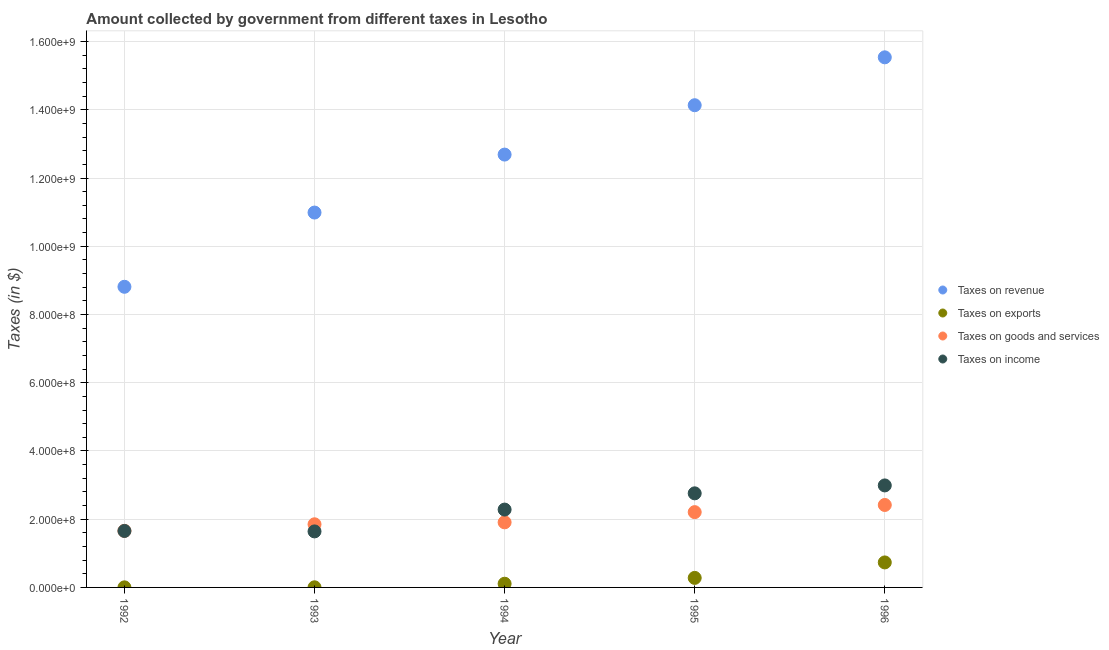How many different coloured dotlines are there?
Keep it short and to the point. 4. What is the amount collected as tax on revenue in 1993?
Your answer should be compact. 1.10e+09. Across all years, what is the maximum amount collected as tax on exports?
Offer a terse response. 7.33e+07. Across all years, what is the minimum amount collected as tax on exports?
Make the answer very short. 2.14e+05. In which year was the amount collected as tax on exports minimum?
Ensure brevity in your answer.  1992. What is the total amount collected as tax on income in the graph?
Your answer should be compact. 1.13e+09. What is the difference between the amount collected as tax on exports in 1995 and that in 1996?
Your answer should be compact. -4.53e+07. What is the difference between the amount collected as tax on exports in 1993 and the amount collected as tax on revenue in 1996?
Offer a terse response. -1.55e+09. What is the average amount collected as tax on exports per year?
Your answer should be very brief. 2.25e+07. In the year 1992, what is the difference between the amount collected as tax on revenue and amount collected as tax on income?
Ensure brevity in your answer.  7.16e+08. In how many years, is the amount collected as tax on exports greater than 680000000 $?
Your answer should be very brief. 0. What is the ratio of the amount collected as tax on revenue in 1994 to that in 1995?
Your answer should be very brief. 0.9. What is the difference between the highest and the second highest amount collected as tax on exports?
Give a very brief answer. 4.53e+07. What is the difference between the highest and the lowest amount collected as tax on income?
Give a very brief answer. 1.35e+08. Is the sum of the amount collected as tax on revenue in 1992 and 1996 greater than the maximum amount collected as tax on income across all years?
Provide a succinct answer. Yes. Is it the case that in every year, the sum of the amount collected as tax on exports and amount collected as tax on revenue is greater than the sum of amount collected as tax on goods and amount collected as tax on income?
Give a very brief answer. Yes. Is it the case that in every year, the sum of the amount collected as tax on revenue and amount collected as tax on exports is greater than the amount collected as tax on goods?
Your answer should be compact. Yes. Does the amount collected as tax on goods monotonically increase over the years?
Your response must be concise. Yes. Is the amount collected as tax on revenue strictly greater than the amount collected as tax on income over the years?
Provide a succinct answer. Yes. Is the amount collected as tax on income strictly less than the amount collected as tax on goods over the years?
Keep it short and to the point. No. How many dotlines are there?
Keep it short and to the point. 4. How many years are there in the graph?
Your answer should be very brief. 5. How many legend labels are there?
Make the answer very short. 4. How are the legend labels stacked?
Offer a terse response. Vertical. What is the title of the graph?
Your answer should be very brief. Amount collected by government from different taxes in Lesotho. Does "Secondary" appear as one of the legend labels in the graph?
Provide a short and direct response. No. What is the label or title of the X-axis?
Ensure brevity in your answer.  Year. What is the label or title of the Y-axis?
Your answer should be very brief. Taxes (in $). What is the Taxes (in $) in Taxes on revenue in 1992?
Your answer should be very brief. 8.81e+08. What is the Taxes (in $) of Taxes on exports in 1992?
Offer a terse response. 2.14e+05. What is the Taxes (in $) of Taxes on goods and services in 1992?
Your answer should be very brief. 1.66e+08. What is the Taxes (in $) of Taxes on income in 1992?
Offer a terse response. 1.66e+08. What is the Taxes (in $) of Taxes on revenue in 1993?
Provide a succinct answer. 1.10e+09. What is the Taxes (in $) of Taxes on exports in 1993?
Keep it short and to the point. 3.65e+05. What is the Taxes (in $) in Taxes on goods and services in 1993?
Provide a short and direct response. 1.85e+08. What is the Taxes (in $) in Taxes on income in 1993?
Provide a succinct answer. 1.64e+08. What is the Taxes (in $) in Taxes on revenue in 1994?
Provide a succinct answer. 1.27e+09. What is the Taxes (in $) in Taxes on exports in 1994?
Make the answer very short. 1.08e+07. What is the Taxes (in $) in Taxes on goods and services in 1994?
Keep it short and to the point. 1.91e+08. What is the Taxes (in $) of Taxes on income in 1994?
Your answer should be compact. 2.28e+08. What is the Taxes (in $) in Taxes on revenue in 1995?
Offer a terse response. 1.41e+09. What is the Taxes (in $) of Taxes on exports in 1995?
Your answer should be very brief. 2.79e+07. What is the Taxes (in $) in Taxes on goods and services in 1995?
Make the answer very short. 2.21e+08. What is the Taxes (in $) of Taxes on income in 1995?
Ensure brevity in your answer.  2.76e+08. What is the Taxes (in $) of Taxes on revenue in 1996?
Your response must be concise. 1.55e+09. What is the Taxes (in $) in Taxes on exports in 1996?
Give a very brief answer. 7.33e+07. What is the Taxes (in $) in Taxes on goods and services in 1996?
Make the answer very short. 2.42e+08. What is the Taxes (in $) in Taxes on income in 1996?
Offer a very short reply. 2.99e+08. Across all years, what is the maximum Taxes (in $) in Taxes on revenue?
Your answer should be compact. 1.55e+09. Across all years, what is the maximum Taxes (in $) of Taxes on exports?
Ensure brevity in your answer.  7.33e+07. Across all years, what is the maximum Taxes (in $) in Taxes on goods and services?
Keep it short and to the point. 2.42e+08. Across all years, what is the maximum Taxes (in $) of Taxes on income?
Ensure brevity in your answer.  2.99e+08. Across all years, what is the minimum Taxes (in $) of Taxes on revenue?
Give a very brief answer. 8.81e+08. Across all years, what is the minimum Taxes (in $) in Taxes on exports?
Offer a very short reply. 2.14e+05. Across all years, what is the minimum Taxes (in $) of Taxes on goods and services?
Provide a succinct answer. 1.66e+08. Across all years, what is the minimum Taxes (in $) of Taxes on income?
Your response must be concise. 1.64e+08. What is the total Taxes (in $) in Taxes on revenue in the graph?
Your response must be concise. 6.22e+09. What is the total Taxes (in $) in Taxes on exports in the graph?
Provide a short and direct response. 1.13e+08. What is the total Taxes (in $) of Taxes on goods and services in the graph?
Your answer should be very brief. 1.00e+09. What is the total Taxes (in $) in Taxes on income in the graph?
Offer a terse response. 1.13e+09. What is the difference between the Taxes (in $) in Taxes on revenue in 1992 and that in 1993?
Offer a terse response. -2.18e+08. What is the difference between the Taxes (in $) of Taxes on exports in 1992 and that in 1993?
Give a very brief answer. -1.51e+05. What is the difference between the Taxes (in $) in Taxes on goods and services in 1992 and that in 1993?
Ensure brevity in your answer.  -1.93e+07. What is the difference between the Taxes (in $) of Taxes on income in 1992 and that in 1993?
Your answer should be compact. 1.33e+06. What is the difference between the Taxes (in $) in Taxes on revenue in 1992 and that in 1994?
Make the answer very short. -3.88e+08. What is the difference between the Taxes (in $) in Taxes on exports in 1992 and that in 1994?
Ensure brevity in your answer.  -1.06e+07. What is the difference between the Taxes (in $) in Taxes on goods and services in 1992 and that in 1994?
Ensure brevity in your answer.  -2.50e+07. What is the difference between the Taxes (in $) in Taxes on income in 1992 and that in 1994?
Offer a terse response. -6.27e+07. What is the difference between the Taxes (in $) of Taxes on revenue in 1992 and that in 1995?
Keep it short and to the point. -5.32e+08. What is the difference between the Taxes (in $) of Taxes on exports in 1992 and that in 1995?
Give a very brief answer. -2.77e+07. What is the difference between the Taxes (in $) in Taxes on goods and services in 1992 and that in 1995?
Your response must be concise. -5.49e+07. What is the difference between the Taxes (in $) of Taxes on income in 1992 and that in 1995?
Provide a short and direct response. -1.10e+08. What is the difference between the Taxes (in $) in Taxes on revenue in 1992 and that in 1996?
Provide a short and direct response. -6.73e+08. What is the difference between the Taxes (in $) in Taxes on exports in 1992 and that in 1996?
Your answer should be very brief. -7.31e+07. What is the difference between the Taxes (in $) of Taxes on goods and services in 1992 and that in 1996?
Keep it short and to the point. -7.59e+07. What is the difference between the Taxes (in $) in Taxes on income in 1992 and that in 1996?
Provide a succinct answer. -1.33e+08. What is the difference between the Taxes (in $) in Taxes on revenue in 1993 and that in 1994?
Offer a very short reply. -1.70e+08. What is the difference between the Taxes (in $) of Taxes on exports in 1993 and that in 1994?
Give a very brief answer. -1.05e+07. What is the difference between the Taxes (in $) in Taxes on goods and services in 1993 and that in 1994?
Offer a very short reply. -5.73e+06. What is the difference between the Taxes (in $) of Taxes on income in 1993 and that in 1994?
Give a very brief answer. -6.40e+07. What is the difference between the Taxes (in $) in Taxes on revenue in 1993 and that in 1995?
Provide a succinct answer. -3.15e+08. What is the difference between the Taxes (in $) of Taxes on exports in 1993 and that in 1995?
Ensure brevity in your answer.  -2.76e+07. What is the difference between the Taxes (in $) of Taxes on goods and services in 1993 and that in 1995?
Your response must be concise. -3.56e+07. What is the difference between the Taxes (in $) of Taxes on income in 1993 and that in 1995?
Give a very brief answer. -1.12e+08. What is the difference between the Taxes (in $) in Taxes on revenue in 1993 and that in 1996?
Offer a terse response. -4.55e+08. What is the difference between the Taxes (in $) of Taxes on exports in 1993 and that in 1996?
Your answer should be very brief. -7.29e+07. What is the difference between the Taxes (in $) in Taxes on goods and services in 1993 and that in 1996?
Offer a terse response. -5.66e+07. What is the difference between the Taxes (in $) of Taxes on income in 1993 and that in 1996?
Offer a terse response. -1.35e+08. What is the difference between the Taxes (in $) of Taxes on revenue in 1994 and that in 1995?
Make the answer very short. -1.45e+08. What is the difference between the Taxes (in $) in Taxes on exports in 1994 and that in 1995?
Make the answer very short. -1.71e+07. What is the difference between the Taxes (in $) of Taxes on goods and services in 1994 and that in 1995?
Offer a terse response. -2.99e+07. What is the difference between the Taxes (in $) in Taxes on income in 1994 and that in 1995?
Offer a terse response. -4.76e+07. What is the difference between the Taxes (in $) in Taxes on revenue in 1994 and that in 1996?
Your answer should be compact. -2.85e+08. What is the difference between the Taxes (in $) in Taxes on exports in 1994 and that in 1996?
Ensure brevity in your answer.  -6.24e+07. What is the difference between the Taxes (in $) of Taxes on goods and services in 1994 and that in 1996?
Your response must be concise. -5.09e+07. What is the difference between the Taxes (in $) in Taxes on income in 1994 and that in 1996?
Keep it short and to the point. -7.08e+07. What is the difference between the Taxes (in $) in Taxes on revenue in 1995 and that in 1996?
Make the answer very short. -1.40e+08. What is the difference between the Taxes (in $) in Taxes on exports in 1995 and that in 1996?
Give a very brief answer. -4.53e+07. What is the difference between the Taxes (in $) of Taxes on goods and services in 1995 and that in 1996?
Provide a succinct answer. -2.10e+07. What is the difference between the Taxes (in $) of Taxes on income in 1995 and that in 1996?
Ensure brevity in your answer.  -2.32e+07. What is the difference between the Taxes (in $) in Taxes on revenue in 1992 and the Taxes (in $) in Taxes on exports in 1993?
Ensure brevity in your answer.  8.81e+08. What is the difference between the Taxes (in $) of Taxes on revenue in 1992 and the Taxes (in $) of Taxes on goods and services in 1993?
Your answer should be very brief. 6.96e+08. What is the difference between the Taxes (in $) of Taxes on revenue in 1992 and the Taxes (in $) of Taxes on income in 1993?
Make the answer very short. 7.17e+08. What is the difference between the Taxes (in $) of Taxes on exports in 1992 and the Taxes (in $) of Taxes on goods and services in 1993?
Make the answer very short. -1.85e+08. What is the difference between the Taxes (in $) in Taxes on exports in 1992 and the Taxes (in $) in Taxes on income in 1993?
Offer a terse response. -1.64e+08. What is the difference between the Taxes (in $) in Taxes on goods and services in 1992 and the Taxes (in $) in Taxes on income in 1993?
Make the answer very short. 1.60e+06. What is the difference between the Taxes (in $) of Taxes on revenue in 1992 and the Taxes (in $) of Taxes on exports in 1994?
Ensure brevity in your answer.  8.70e+08. What is the difference between the Taxes (in $) in Taxes on revenue in 1992 and the Taxes (in $) in Taxes on goods and services in 1994?
Your response must be concise. 6.90e+08. What is the difference between the Taxes (in $) of Taxes on revenue in 1992 and the Taxes (in $) of Taxes on income in 1994?
Keep it short and to the point. 6.53e+08. What is the difference between the Taxes (in $) of Taxes on exports in 1992 and the Taxes (in $) of Taxes on goods and services in 1994?
Provide a succinct answer. -1.91e+08. What is the difference between the Taxes (in $) in Taxes on exports in 1992 and the Taxes (in $) in Taxes on income in 1994?
Ensure brevity in your answer.  -2.28e+08. What is the difference between the Taxes (in $) of Taxes on goods and services in 1992 and the Taxes (in $) of Taxes on income in 1994?
Offer a terse response. -6.24e+07. What is the difference between the Taxes (in $) in Taxes on revenue in 1992 and the Taxes (in $) in Taxes on exports in 1995?
Give a very brief answer. 8.53e+08. What is the difference between the Taxes (in $) in Taxes on revenue in 1992 and the Taxes (in $) in Taxes on goods and services in 1995?
Provide a succinct answer. 6.61e+08. What is the difference between the Taxes (in $) in Taxes on revenue in 1992 and the Taxes (in $) in Taxes on income in 1995?
Make the answer very short. 6.05e+08. What is the difference between the Taxes (in $) in Taxes on exports in 1992 and the Taxes (in $) in Taxes on goods and services in 1995?
Your response must be concise. -2.20e+08. What is the difference between the Taxes (in $) of Taxes on exports in 1992 and the Taxes (in $) of Taxes on income in 1995?
Keep it short and to the point. -2.76e+08. What is the difference between the Taxes (in $) of Taxes on goods and services in 1992 and the Taxes (in $) of Taxes on income in 1995?
Provide a short and direct response. -1.10e+08. What is the difference between the Taxes (in $) in Taxes on revenue in 1992 and the Taxes (in $) in Taxes on exports in 1996?
Give a very brief answer. 8.08e+08. What is the difference between the Taxes (in $) of Taxes on revenue in 1992 and the Taxes (in $) of Taxes on goods and services in 1996?
Provide a short and direct response. 6.40e+08. What is the difference between the Taxes (in $) of Taxes on revenue in 1992 and the Taxes (in $) of Taxes on income in 1996?
Keep it short and to the point. 5.82e+08. What is the difference between the Taxes (in $) in Taxes on exports in 1992 and the Taxes (in $) in Taxes on goods and services in 1996?
Offer a very short reply. -2.41e+08. What is the difference between the Taxes (in $) in Taxes on exports in 1992 and the Taxes (in $) in Taxes on income in 1996?
Make the answer very short. -2.99e+08. What is the difference between the Taxes (in $) of Taxes on goods and services in 1992 and the Taxes (in $) of Taxes on income in 1996?
Make the answer very short. -1.33e+08. What is the difference between the Taxes (in $) in Taxes on revenue in 1993 and the Taxes (in $) in Taxes on exports in 1994?
Offer a very short reply. 1.09e+09. What is the difference between the Taxes (in $) in Taxes on revenue in 1993 and the Taxes (in $) in Taxes on goods and services in 1994?
Your response must be concise. 9.08e+08. What is the difference between the Taxes (in $) of Taxes on revenue in 1993 and the Taxes (in $) of Taxes on income in 1994?
Your response must be concise. 8.71e+08. What is the difference between the Taxes (in $) in Taxes on exports in 1993 and the Taxes (in $) in Taxes on goods and services in 1994?
Offer a very short reply. -1.90e+08. What is the difference between the Taxes (in $) in Taxes on exports in 1993 and the Taxes (in $) in Taxes on income in 1994?
Your answer should be compact. -2.28e+08. What is the difference between the Taxes (in $) in Taxes on goods and services in 1993 and the Taxes (in $) in Taxes on income in 1994?
Offer a very short reply. -4.31e+07. What is the difference between the Taxes (in $) of Taxes on revenue in 1993 and the Taxes (in $) of Taxes on exports in 1995?
Provide a succinct answer. 1.07e+09. What is the difference between the Taxes (in $) in Taxes on revenue in 1993 and the Taxes (in $) in Taxes on goods and services in 1995?
Provide a short and direct response. 8.78e+08. What is the difference between the Taxes (in $) of Taxes on revenue in 1993 and the Taxes (in $) of Taxes on income in 1995?
Offer a terse response. 8.23e+08. What is the difference between the Taxes (in $) in Taxes on exports in 1993 and the Taxes (in $) in Taxes on goods and services in 1995?
Keep it short and to the point. -2.20e+08. What is the difference between the Taxes (in $) of Taxes on exports in 1993 and the Taxes (in $) of Taxes on income in 1995?
Your answer should be very brief. -2.75e+08. What is the difference between the Taxes (in $) in Taxes on goods and services in 1993 and the Taxes (in $) in Taxes on income in 1995?
Offer a very short reply. -9.07e+07. What is the difference between the Taxes (in $) in Taxes on revenue in 1993 and the Taxes (in $) in Taxes on exports in 1996?
Make the answer very short. 1.03e+09. What is the difference between the Taxes (in $) of Taxes on revenue in 1993 and the Taxes (in $) of Taxes on goods and services in 1996?
Your answer should be compact. 8.57e+08. What is the difference between the Taxes (in $) in Taxes on revenue in 1993 and the Taxes (in $) in Taxes on income in 1996?
Provide a short and direct response. 8.00e+08. What is the difference between the Taxes (in $) in Taxes on exports in 1993 and the Taxes (in $) in Taxes on goods and services in 1996?
Your answer should be very brief. -2.41e+08. What is the difference between the Taxes (in $) in Taxes on exports in 1993 and the Taxes (in $) in Taxes on income in 1996?
Keep it short and to the point. -2.99e+08. What is the difference between the Taxes (in $) in Taxes on goods and services in 1993 and the Taxes (in $) in Taxes on income in 1996?
Provide a succinct answer. -1.14e+08. What is the difference between the Taxes (in $) of Taxes on revenue in 1994 and the Taxes (in $) of Taxes on exports in 1995?
Offer a very short reply. 1.24e+09. What is the difference between the Taxes (in $) of Taxes on revenue in 1994 and the Taxes (in $) of Taxes on goods and services in 1995?
Provide a short and direct response. 1.05e+09. What is the difference between the Taxes (in $) in Taxes on revenue in 1994 and the Taxes (in $) in Taxes on income in 1995?
Give a very brief answer. 9.93e+08. What is the difference between the Taxes (in $) in Taxes on exports in 1994 and the Taxes (in $) in Taxes on goods and services in 1995?
Keep it short and to the point. -2.10e+08. What is the difference between the Taxes (in $) of Taxes on exports in 1994 and the Taxes (in $) of Taxes on income in 1995?
Your answer should be very brief. -2.65e+08. What is the difference between the Taxes (in $) in Taxes on goods and services in 1994 and the Taxes (in $) in Taxes on income in 1995?
Provide a succinct answer. -8.50e+07. What is the difference between the Taxes (in $) of Taxes on revenue in 1994 and the Taxes (in $) of Taxes on exports in 1996?
Your response must be concise. 1.20e+09. What is the difference between the Taxes (in $) of Taxes on revenue in 1994 and the Taxes (in $) of Taxes on goods and services in 1996?
Offer a terse response. 1.03e+09. What is the difference between the Taxes (in $) in Taxes on revenue in 1994 and the Taxes (in $) in Taxes on income in 1996?
Make the answer very short. 9.70e+08. What is the difference between the Taxes (in $) of Taxes on exports in 1994 and the Taxes (in $) of Taxes on goods and services in 1996?
Your response must be concise. -2.31e+08. What is the difference between the Taxes (in $) in Taxes on exports in 1994 and the Taxes (in $) in Taxes on income in 1996?
Offer a very short reply. -2.88e+08. What is the difference between the Taxes (in $) of Taxes on goods and services in 1994 and the Taxes (in $) of Taxes on income in 1996?
Your response must be concise. -1.08e+08. What is the difference between the Taxes (in $) in Taxes on revenue in 1995 and the Taxes (in $) in Taxes on exports in 1996?
Offer a very short reply. 1.34e+09. What is the difference between the Taxes (in $) in Taxes on revenue in 1995 and the Taxes (in $) in Taxes on goods and services in 1996?
Ensure brevity in your answer.  1.17e+09. What is the difference between the Taxes (in $) of Taxes on revenue in 1995 and the Taxes (in $) of Taxes on income in 1996?
Provide a short and direct response. 1.11e+09. What is the difference between the Taxes (in $) in Taxes on exports in 1995 and the Taxes (in $) in Taxes on goods and services in 1996?
Ensure brevity in your answer.  -2.14e+08. What is the difference between the Taxes (in $) in Taxes on exports in 1995 and the Taxes (in $) in Taxes on income in 1996?
Provide a succinct answer. -2.71e+08. What is the difference between the Taxes (in $) of Taxes on goods and services in 1995 and the Taxes (in $) of Taxes on income in 1996?
Ensure brevity in your answer.  -7.83e+07. What is the average Taxes (in $) of Taxes on revenue per year?
Offer a very short reply. 1.24e+09. What is the average Taxes (in $) of Taxes on exports per year?
Ensure brevity in your answer.  2.25e+07. What is the average Taxes (in $) in Taxes on goods and services per year?
Offer a terse response. 2.01e+08. What is the average Taxes (in $) of Taxes on income per year?
Ensure brevity in your answer.  2.27e+08. In the year 1992, what is the difference between the Taxes (in $) of Taxes on revenue and Taxes (in $) of Taxes on exports?
Your answer should be very brief. 8.81e+08. In the year 1992, what is the difference between the Taxes (in $) of Taxes on revenue and Taxes (in $) of Taxes on goods and services?
Give a very brief answer. 7.15e+08. In the year 1992, what is the difference between the Taxes (in $) in Taxes on revenue and Taxes (in $) in Taxes on income?
Ensure brevity in your answer.  7.16e+08. In the year 1992, what is the difference between the Taxes (in $) of Taxes on exports and Taxes (in $) of Taxes on goods and services?
Your response must be concise. -1.66e+08. In the year 1992, what is the difference between the Taxes (in $) of Taxes on exports and Taxes (in $) of Taxes on income?
Provide a short and direct response. -1.65e+08. In the year 1992, what is the difference between the Taxes (in $) in Taxes on goods and services and Taxes (in $) in Taxes on income?
Give a very brief answer. 2.68e+05. In the year 1993, what is the difference between the Taxes (in $) in Taxes on revenue and Taxes (in $) in Taxes on exports?
Provide a short and direct response. 1.10e+09. In the year 1993, what is the difference between the Taxes (in $) of Taxes on revenue and Taxes (in $) of Taxes on goods and services?
Your response must be concise. 9.14e+08. In the year 1993, what is the difference between the Taxes (in $) of Taxes on revenue and Taxes (in $) of Taxes on income?
Provide a succinct answer. 9.35e+08. In the year 1993, what is the difference between the Taxes (in $) in Taxes on exports and Taxes (in $) in Taxes on goods and services?
Your answer should be compact. -1.85e+08. In the year 1993, what is the difference between the Taxes (in $) in Taxes on exports and Taxes (in $) in Taxes on income?
Your answer should be compact. -1.64e+08. In the year 1993, what is the difference between the Taxes (in $) of Taxes on goods and services and Taxes (in $) of Taxes on income?
Offer a terse response. 2.09e+07. In the year 1994, what is the difference between the Taxes (in $) in Taxes on revenue and Taxes (in $) in Taxes on exports?
Make the answer very short. 1.26e+09. In the year 1994, what is the difference between the Taxes (in $) of Taxes on revenue and Taxes (in $) of Taxes on goods and services?
Ensure brevity in your answer.  1.08e+09. In the year 1994, what is the difference between the Taxes (in $) in Taxes on revenue and Taxes (in $) in Taxes on income?
Your response must be concise. 1.04e+09. In the year 1994, what is the difference between the Taxes (in $) in Taxes on exports and Taxes (in $) in Taxes on goods and services?
Give a very brief answer. -1.80e+08. In the year 1994, what is the difference between the Taxes (in $) of Taxes on exports and Taxes (in $) of Taxes on income?
Make the answer very short. -2.17e+08. In the year 1994, what is the difference between the Taxes (in $) in Taxes on goods and services and Taxes (in $) in Taxes on income?
Provide a succinct answer. -3.74e+07. In the year 1995, what is the difference between the Taxes (in $) in Taxes on revenue and Taxes (in $) in Taxes on exports?
Make the answer very short. 1.39e+09. In the year 1995, what is the difference between the Taxes (in $) of Taxes on revenue and Taxes (in $) of Taxes on goods and services?
Make the answer very short. 1.19e+09. In the year 1995, what is the difference between the Taxes (in $) of Taxes on revenue and Taxes (in $) of Taxes on income?
Offer a terse response. 1.14e+09. In the year 1995, what is the difference between the Taxes (in $) of Taxes on exports and Taxes (in $) of Taxes on goods and services?
Keep it short and to the point. -1.93e+08. In the year 1995, what is the difference between the Taxes (in $) in Taxes on exports and Taxes (in $) in Taxes on income?
Offer a terse response. -2.48e+08. In the year 1995, what is the difference between the Taxes (in $) of Taxes on goods and services and Taxes (in $) of Taxes on income?
Keep it short and to the point. -5.51e+07. In the year 1996, what is the difference between the Taxes (in $) of Taxes on revenue and Taxes (in $) of Taxes on exports?
Your answer should be compact. 1.48e+09. In the year 1996, what is the difference between the Taxes (in $) in Taxes on revenue and Taxes (in $) in Taxes on goods and services?
Your answer should be very brief. 1.31e+09. In the year 1996, what is the difference between the Taxes (in $) in Taxes on revenue and Taxes (in $) in Taxes on income?
Make the answer very short. 1.25e+09. In the year 1996, what is the difference between the Taxes (in $) of Taxes on exports and Taxes (in $) of Taxes on goods and services?
Your response must be concise. -1.68e+08. In the year 1996, what is the difference between the Taxes (in $) of Taxes on exports and Taxes (in $) of Taxes on income?
Offer a very short reply. -2.26e+08. In the year 1996, what is the difference between the Taxes (in $) in Taxes on goods and services and Taxes (in $) in Taxes on income?
Offer a very short reply. -5.73e+07. What is the ratio of the Taxes (in $) in Taxes on revenue in 1992 to that in 1993?
Make the answer very short. 0.8. What is the ratio of the Taxes (in $) of Taxes on exports in 1992 to that in 1993?
Make the answer very short. 0.59. What is the ratio of the Taxes (in $) of Taxes on goods and services in 1992 to that in 1993?
Offer a very short reply. 0.9. What is the ratio of the Taxes (in $) in Taxes on income in 1992 to that in 1993?
Provide a short and direct response. 1.01. What is the ratio of the Taxes (in $) of Taxes on revenue in 1992 to that in 1994?
Make the answer very short. 0.69. What is the ratio of the Taxes (in $) of Taxes on exports in 1992 to that in 1994?
Offer a very short reply. 0.02. What is the ratio of the Taxes (in $) in Taxes on goods and services in 1992 to that in 1994?
Give a very brief answer. 0.87. What is the ratio of the Taxes (in $) of Taxes on income in 1992 to that in 1994?
Give a very brief answer. 0.73. What is the ratio of the Taxes (in $) in Taxes on revenue in 1992 to that in 1995?
Offer a terse response. 0.62. What is the ratio of the Taxes (in $) of Taxes on exports in 1992 to that in 1995?
Make the answer very short. 0.01. What is the ratio of the Taxes (in $) in Taxes on goods and services in 1992 to that in 1995?
Offer a very short reply. 0.75. What is the ratio of the Taxes (in $) in Taxes on income in 1992 to that in 1995?
Ensure brevity in your answer.  0.6. What is the ratio of the Taxes (in $) in Taxes on revenue in 1992 to that in 1996?
Ensure brevity in your answer.  0.57. What is the ratio of the Taxes (in $) in Taxes on exports in 1992 to that in 1996?
Your answer should be compact. 0. What is the ratio of the Taxes (in $) of Taxes on goods and services in 1992 to that in 1996?
Offer a terse response. 0.69. What is the ratio of the Taxes (in $) of Taxes on income in 1992 to that in 1996?
Provide a succinct answer. 0.55. What is the ratio of the Taxes (in $) in Taxes on revenue in 1993 to that in 1994?
Your answer should be compact. 0.87. What is the ratio of the Taxes (in $) in Taxes on exports in 1993 to that in 1994?
Offer a terse response. 0.03. What is the ratio of the Taxes (in $) of Taxes on goods and services in 1993 to that in 1994?
Provide a short and direct response. 0.97. What is the ratio of the Taxes (in $) of Taxes on income in 1993 to that in 1994?
Your answer should be very brief. 0.72. What is the ratio of the Taxes (in $) of Taxes on revenue in 1993 to that in 1995?
Give a very brief answer. 0.78. What is the ratio of the Taxes (in $) in Taxes on exports in 1993 to that in 1995?
Your answer should be compact. 0.01. What is the ratio of the Taxes (in $) of Taxes on goods and services in 1993 to that in 1995?
Your answer should be compact. 0.84. What is the ratio of the Taxes (in $) of Taxes on income in 1993 to that in 1995?
Provide a succinct answer. 0.6. What is the ratio of the Taxes (in $) of Taxes on revenue in 1993 to that in 1996?
Offer a very short reply. 0.71. What is the ratio of the Taxes (in $) of Taxes on exports in 1993 to that in 1996?
Provide a short and direct response. 0.01. What is the ratio of the Taxes (in $) of Taxes on goods and services in 1993 to that in 1996?
Offer a terse response. 0.77. What is the ratio of the Taxes (in $) of Taxes on income in 1993 to that in 1996?
Provide a short and direct response. 0.55. What is the ratio of the Taxes (in $) of Taxes on revenue in 1994 to that in 1995?
Provide a succinct answer. 0.9. What is the ratio of the Taxes (in $) in Taxes on exports in 1994 to that in 1995?
Make the answer very short. 0.39. What is the ratio of the Taxes (in $) of Taxes on goods and services in 1994 to that in 1995?
Your answer should be very brief. 0.86. What is the ratio of the Taxes (in $) in Taxes on income in 1994 to that in 1995?
Give a very brief answer. 0.83. What is the ratio of the Taxes (in $) of Taxes on revenue in 1994 to that in 1996?
Give a very brief answer. 0.82. What is the ratio of the Taxes (in $) of Taxes on exports in 1994 to that in 1996?
Your answer should be very brief. 0.15. What is the ratio of the Taxes (in $) in Taxes on goods and services in 1994 to that in 1996?
Ensure brevity in your answer.  0.79. What is the ratio of the Taxes (in $) of Taxes on income in 1994 to that in 1996?
Your answer should be very brief. 0.76. What is the ratio of the Taxes (in $) of Taxes on revenue in 1995 to that in 1996?
Your response must be concise. 0.91. What is the ratio of the Taxes (in $) of Taxes on exports in 1995 to that in 1996?
Provide a short and direct response. 0.38. What is the ratio of the Taxes (in $) of Taxes on goods and services in 1995 to that in 1996?
Provide a succinct answer. 0.91. What is the ratio of the Taxes (in $) in Taxes on income in 1995 to that in 1996?
Make the answer very short. 0.92. What is the difference between the highest and the second highest Taxes (in $) of Taxes on revenue?
Give a very brief answer. 1.40e+08. What is the difference between the highest and the second highest Taxes (in $) in Taxes on exports?
Ensure brevity in your answer.  4.53e+07. What is the difference between the highest and the second highest Taxes (in $) in Taxes on goods and services?
Offer a very short reply. 2.10e+07. What is the difference between the highest and the second highest Taxes (in $) in Taxes on income?
Offer a very short reply. 2.32e+07. What is the difference between the highest and the lowest Taxes (in $) in Taxes on revenue?
Your answer should be compact. 6.73e+08. What is the difference between the highest and the lowest Taxes (in $) of Taxes on exports?
Offer a very short reply. 7.31e+07. What is the difference between the highest and the lowest Taxes (in $) of Taxes on goods and services?
Provide a short and direct response. 7.59e+07. What is the difference between the highest and the lowest Taxes (in $) in Taxes on income?
Offer a terse response. 1.35e+08. 